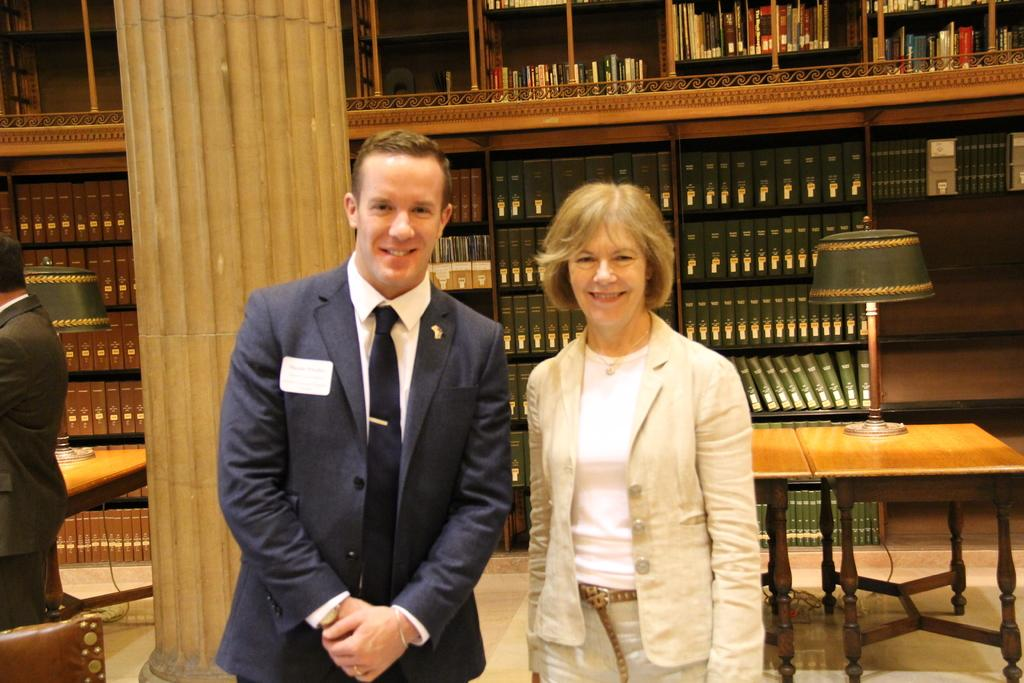How many people are in the image? There are two persons standing in the center of the image. What is the facial expression of the people in the image? The two persons are smiling. What can be seen in the background of the image? There is a wood wall, a table, a lamp, and books in the background of the image. What color is the group of people in the image? There is no group of people in the image; there are only two persons. Additionally, colors cannot be attributed to people. 